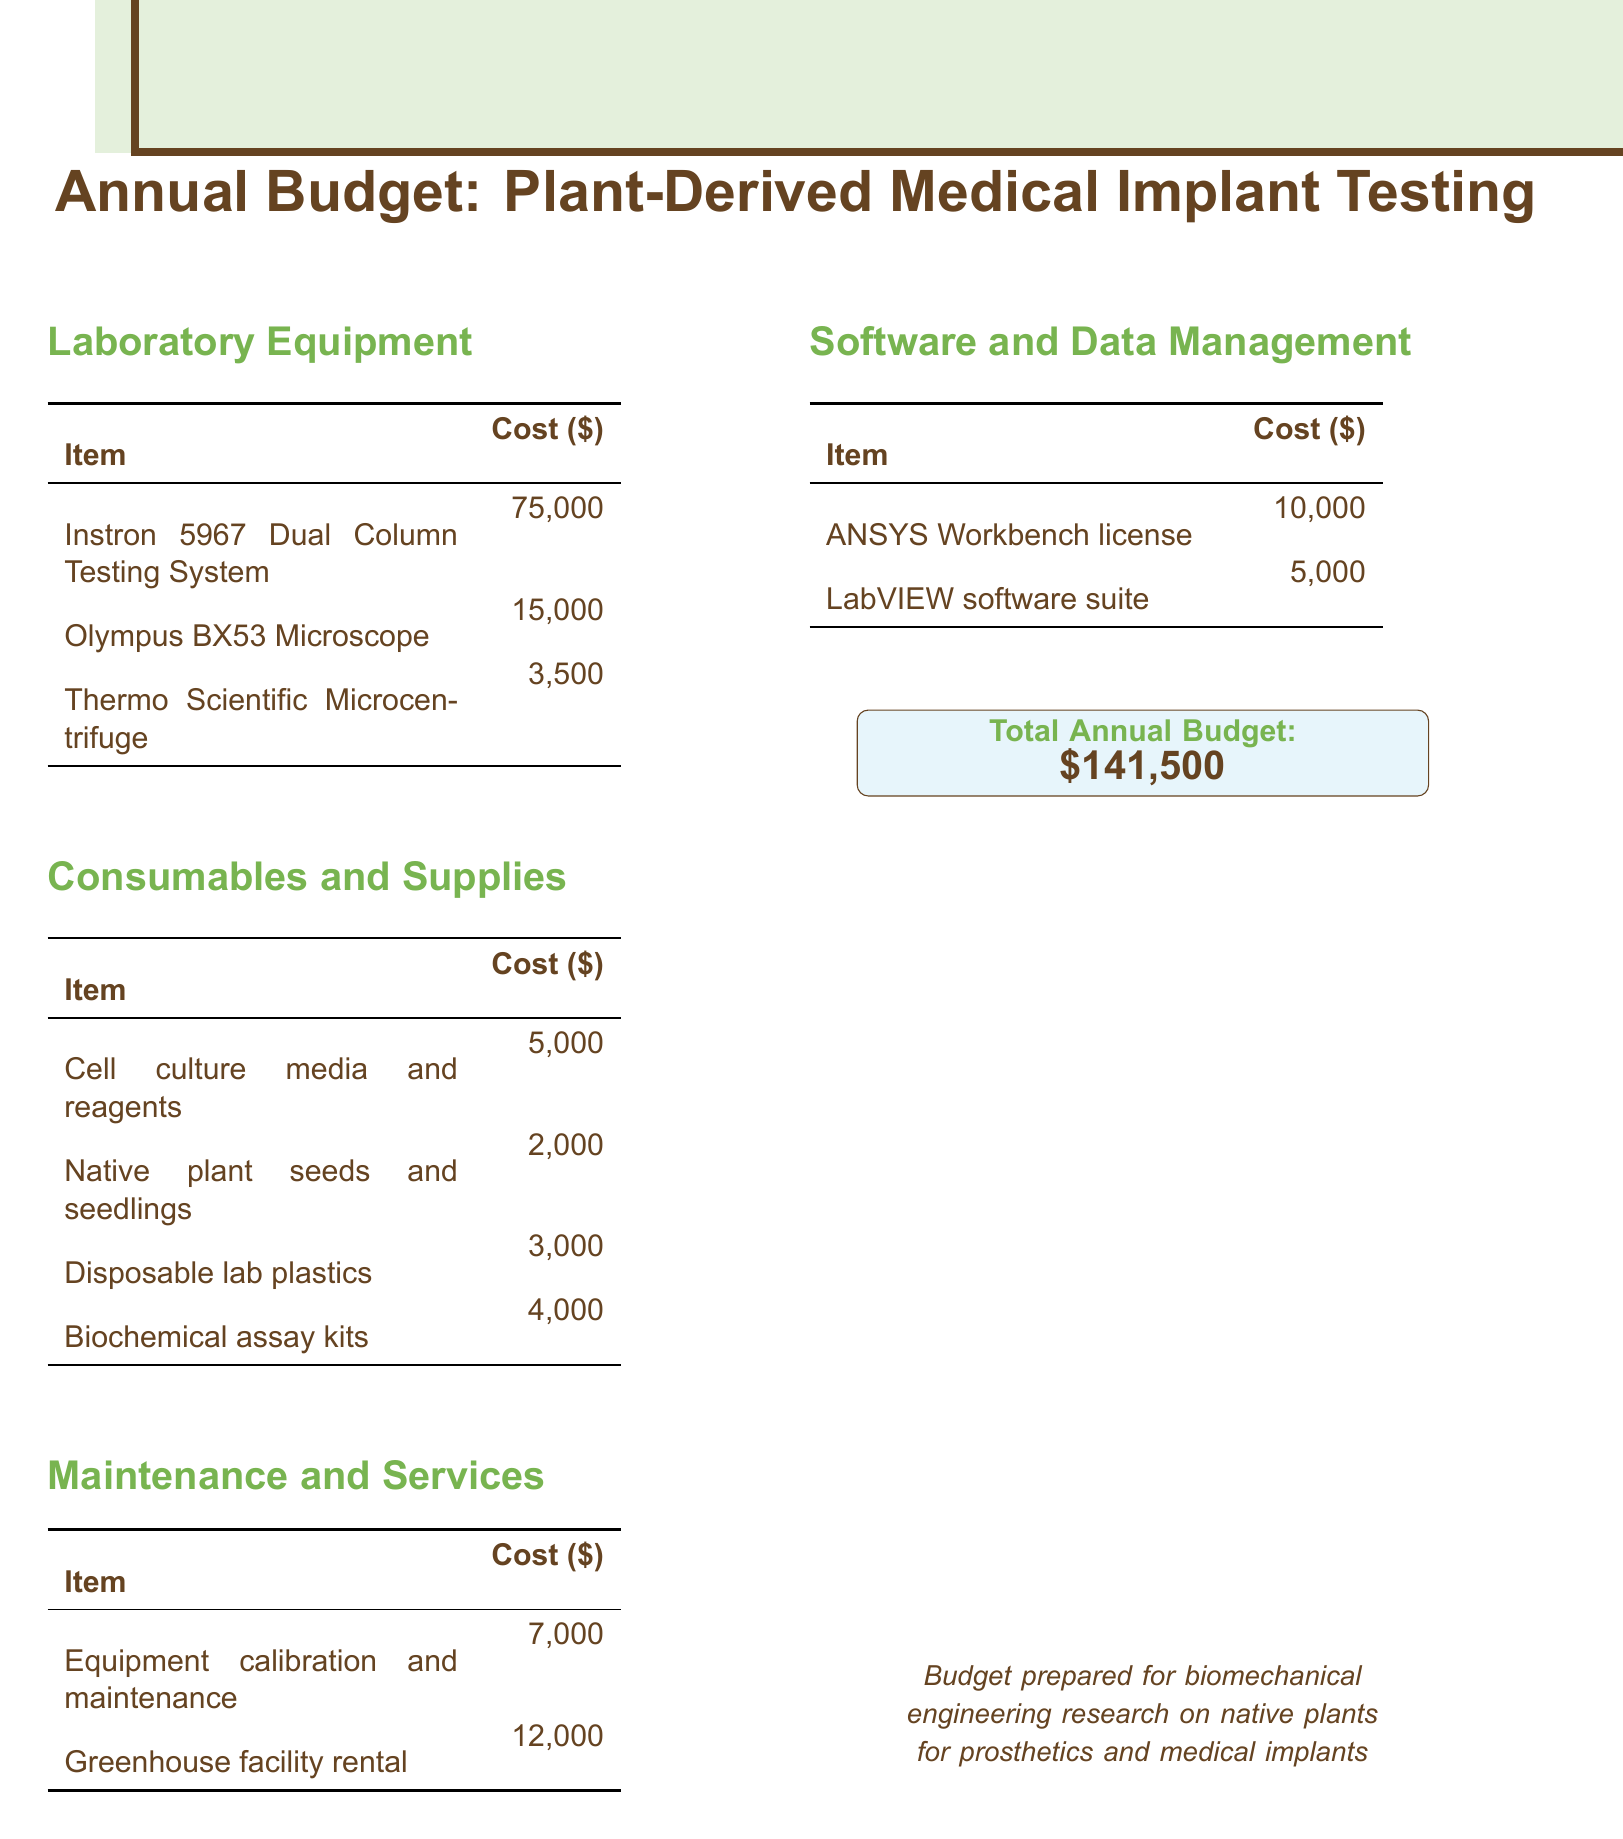what is the total annual budget? The total annual budget is listed as the final amount in the document.
Answer: $141,500 how much does the Instron 5967 Dual Column Testing System cost? The cost of the Instron 5967 Dual Column Testing System is stated in the laboratory equipment section.
Answer: $75,000 what are the two main categories of expenses in the budget? The document outlines several categories, with laboratory equipment and consumables being prominent.
Answer: Laboratory Equipment and Consumables how much is allocated for equipment calibration and maintenance? The cost for equipment calibration and maintenance is mentioned in the maintenance and services section.
Answer: $7,000 which software license costs $10,000? The software cost is listed and corresponds to one specific software title in the document.
Answer: ANSYS Workbench license how much is budgeted for native plant seeds and seedlings? The cost for native plant seeds and seedlings is part of the consumables and supplies section of the budget.
Answer: $2,000 what is the total cost of maintenance and services? The total in this category is the sum of the costs provided in the maintenance and services section.
Answer: $19,000 what item costs the least in laboratory equipment? Among the listed items in laboratory equipment, the one with the lowest cost is found in that section.
Answer: Thermo Scientific Microcentrifuge how much is allocated for greenhouse facility rental? The cost for greenhouse facility rental is specified under the maintenance and services section.
Answer: $12,000 